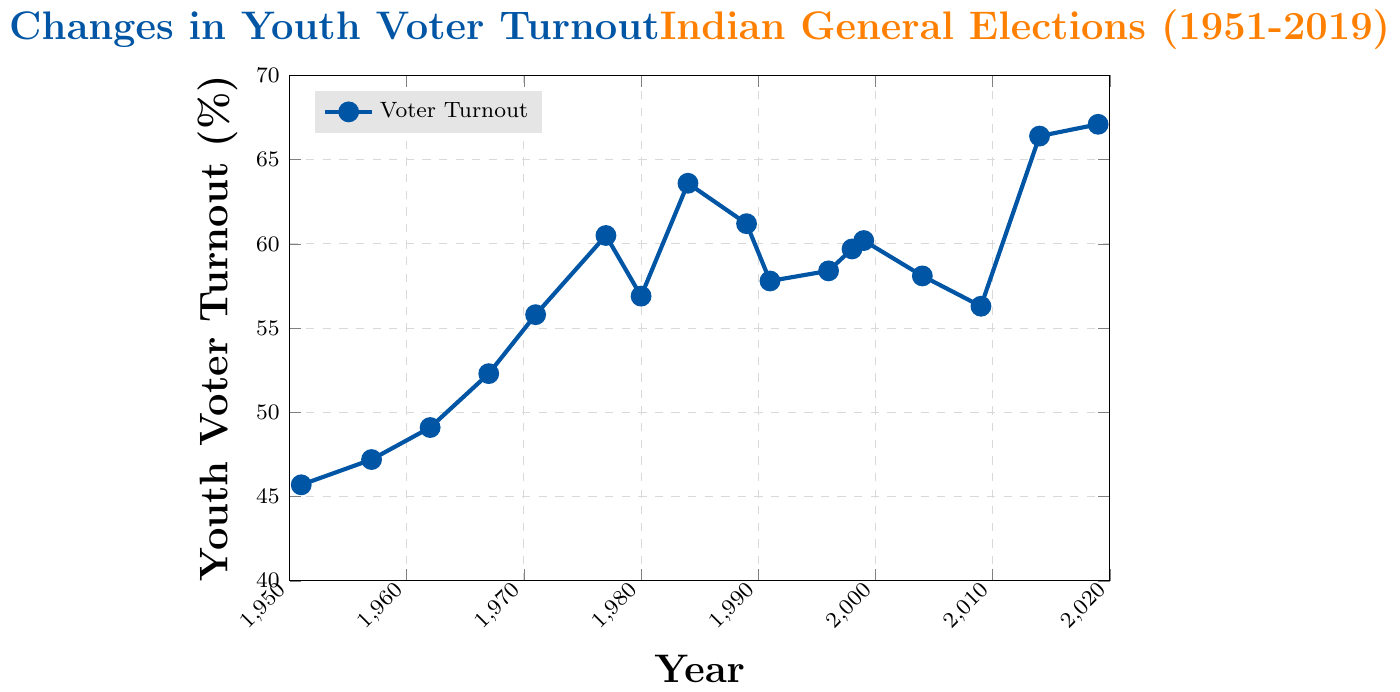What's the median youth voter turnout between 1951 and 2019? To find the median, list the turnout values in ascending order: 45.7, 47.2, 49.1, 52.3, 55.8, 56.3, 56.9, 57.8, 58.1, 58.4, 59.7, 60.2, 60.5, 61.2, 63.6, 66.4, 67.1. The median is the middle value, which is the 9th value here: 58.1
Answer: 58.1 In which year was the youth voter turnout the highest? Identify the highest value on the y-axis, then locate the corresponding year on the x-axis. The highest value is 67.1% in 2019.
Answer: 2019 How much did the youth voter turnout change from 1951 to 2019? Subtract the voter turnout in 1951 from the turnout in 2019: 67.1% - 45.7% = 21.4%.
Answer: 21.4% Did youth voter turnout ever exceed 60% before the year 2000? Check data points before the year 2000 and see if any values exceed 60%. In 1977, 1984, 1989, 1998, and 1999, turnout exceeded 60%.
Answer: Yes What is the average youth voter turnout from 1951 to 2019? Add all the turnout values and divide by the number of values: (45.7 + 47.2 + 49.1 + 52.3 + 55.8 + 60.5 + 56.9 + 63.6 + 61.2 + 57.8 + 58.4 + 59.7 + 60.2 + 58.1 + 56.3 + 66.4 + 67.1) / 17 ≈ 57.3
Answer: 57.3 Which decade saw the largest increase in youth voter turnout? Calculate the differences for each decade: 
1951-1961: 49.1-45.7 = 3.4, 
1961-1971: 55.8-49.1 = 6.7, 
1971-1981: 60.5-55.8 = 4.7, 
1981-1991: 61.2-56.9 = 4.3, 
1991-2001: 60.2-57.8 = 2.4, 
2001-2011: 56.3-58.1 = -1.8, 
2011-2019: 67.1-56.3 = 10.8. 
The largest increase is from 2011-2019.
Answer: 2011-2019 Was there a period where the youth voter turnout consistently declined? Identify periods where successive data points decrease: from 1977 to 1980, from 1984 to 1991, from 2004 to 2009.
Answer: Yes What was the youth voter turnout in 1984? Locate the value corresponding to the year 1984: 63.6%.
Answer: 63.6 Compare the youth voter turnout in 1967 and 2014. Which year had higher turnout and by how much? Subtract the 1967 turnout from the 2014 turnout: 66.4% - 52.3% = 14.1%. 2014 had a higher turnout by 14.1%.
Answer: 2014 by 14.1% 